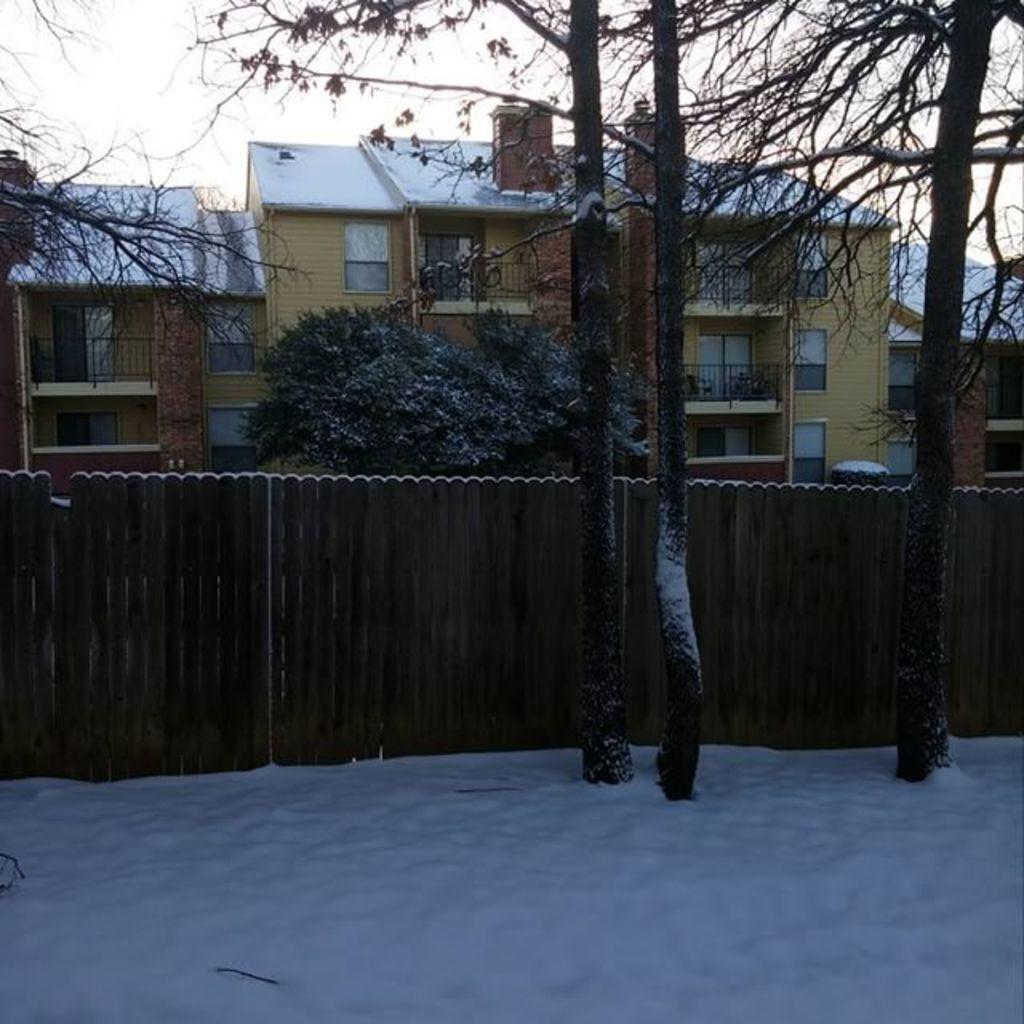Could you give a brief overview of what you see in this image? These are the houses with the windows. I can see the trees. This looks like a wooden fence. I think this is the snow. This looks like the sky. 